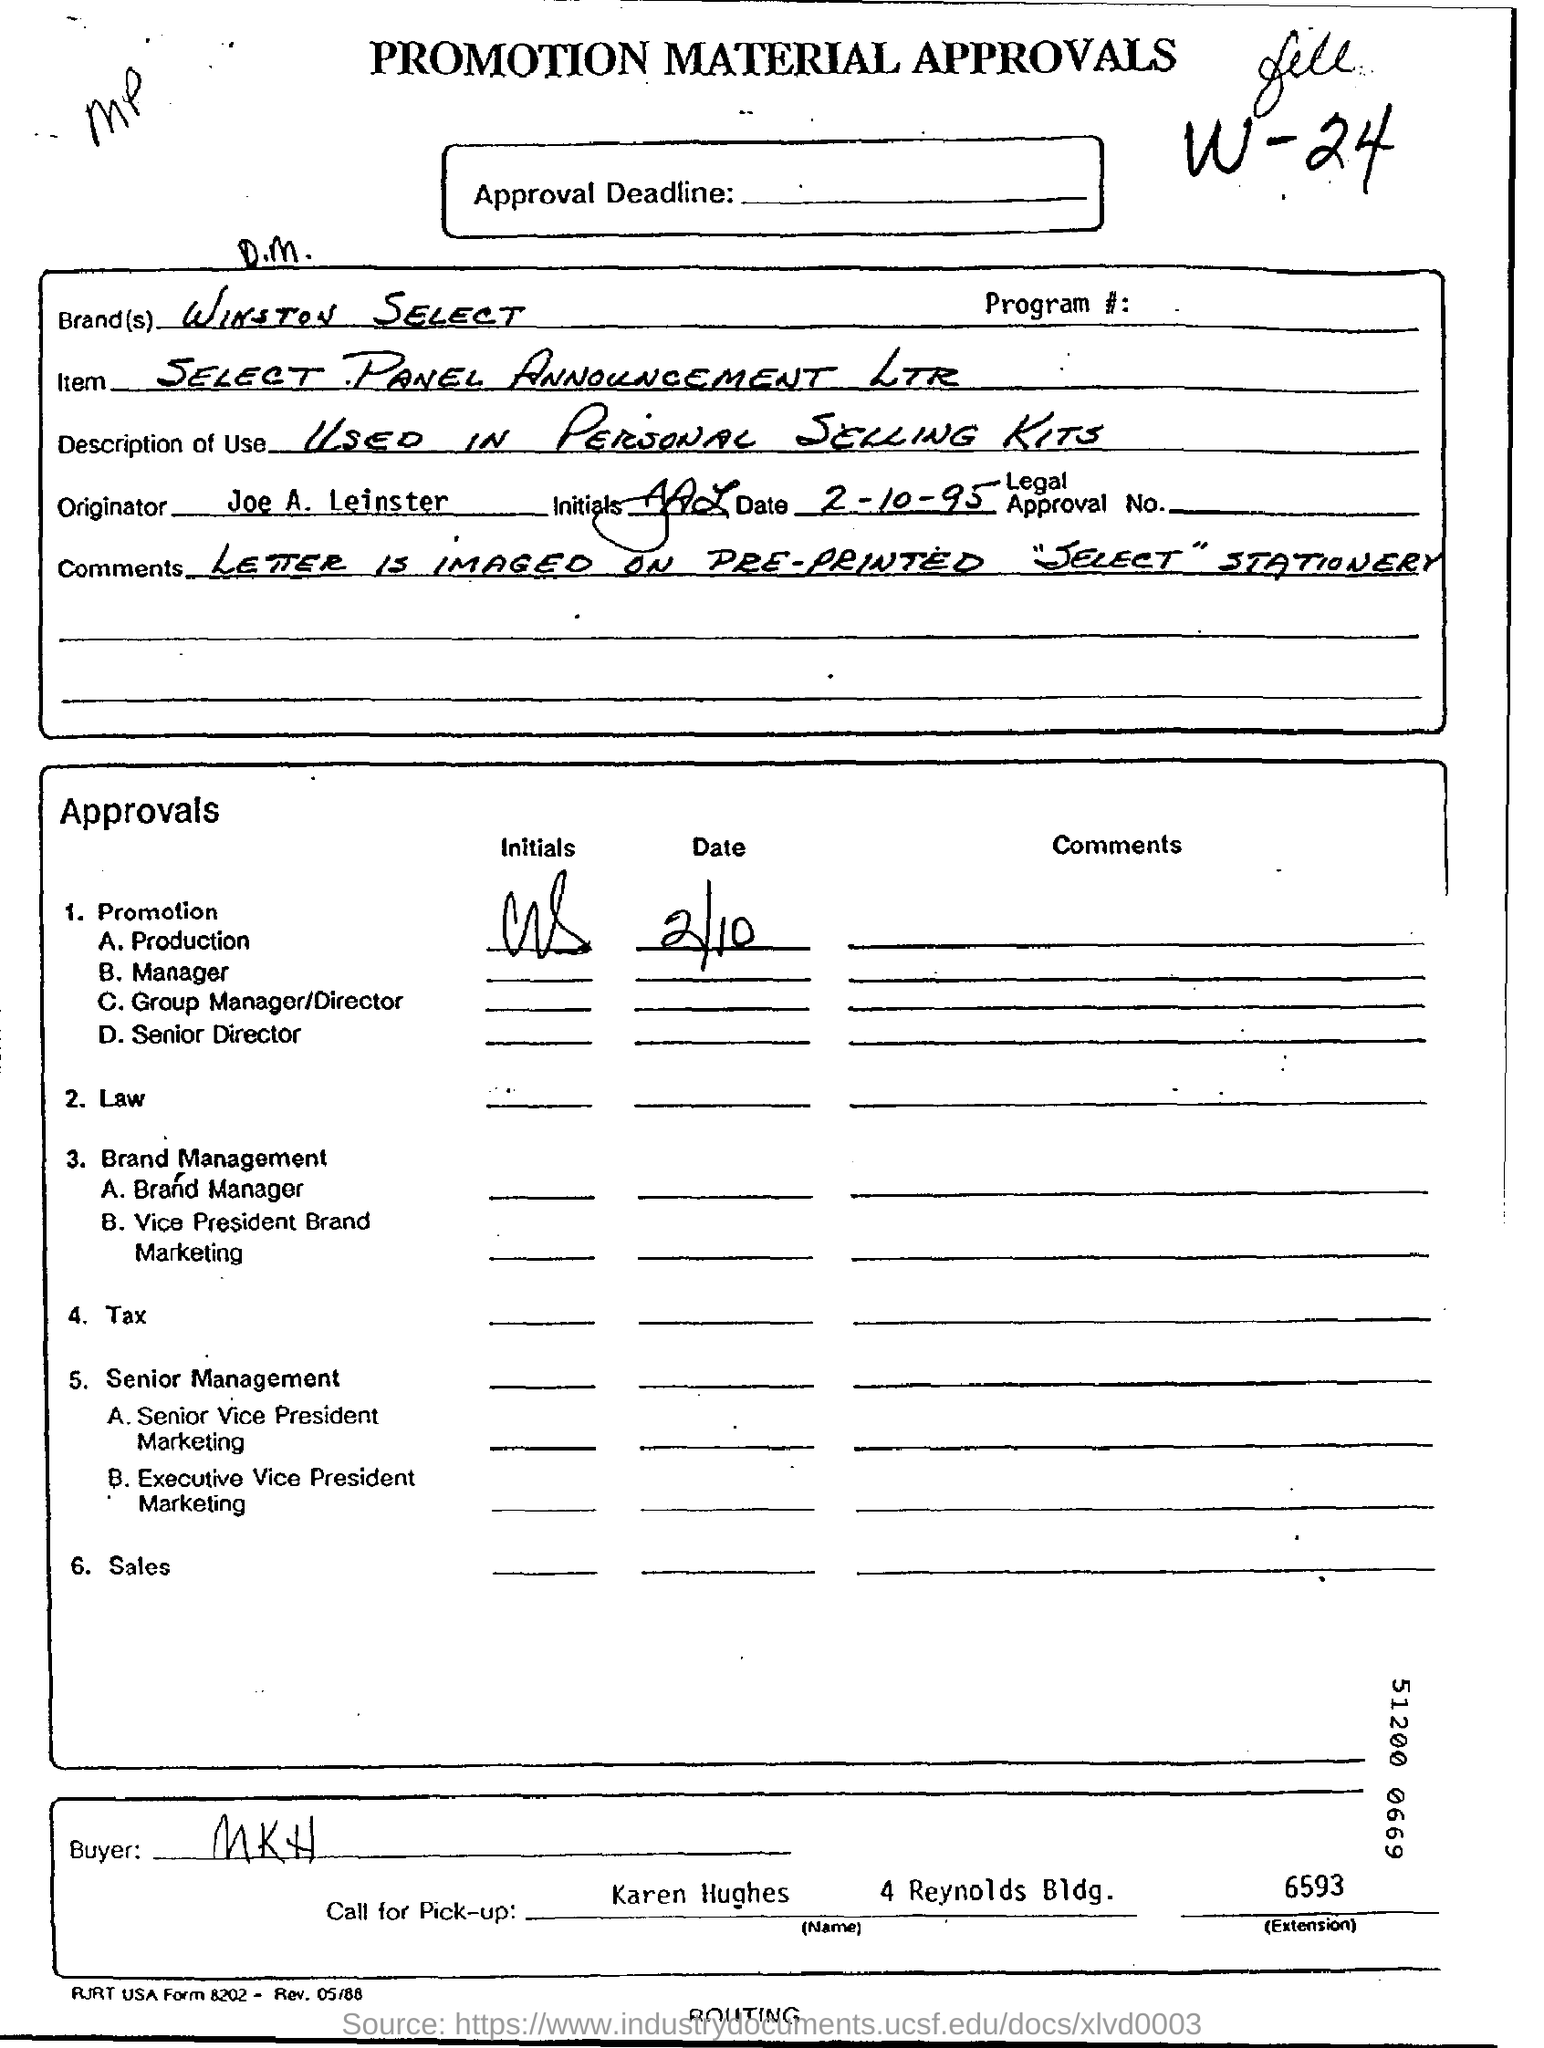Draw attention to some important aspects in this diagram. Karen Hughes will be responsible for taking the call for pick-up. WINSTON SELECT is the brand name. The originator is Joe A. Leinster. The buyer is MKH. 